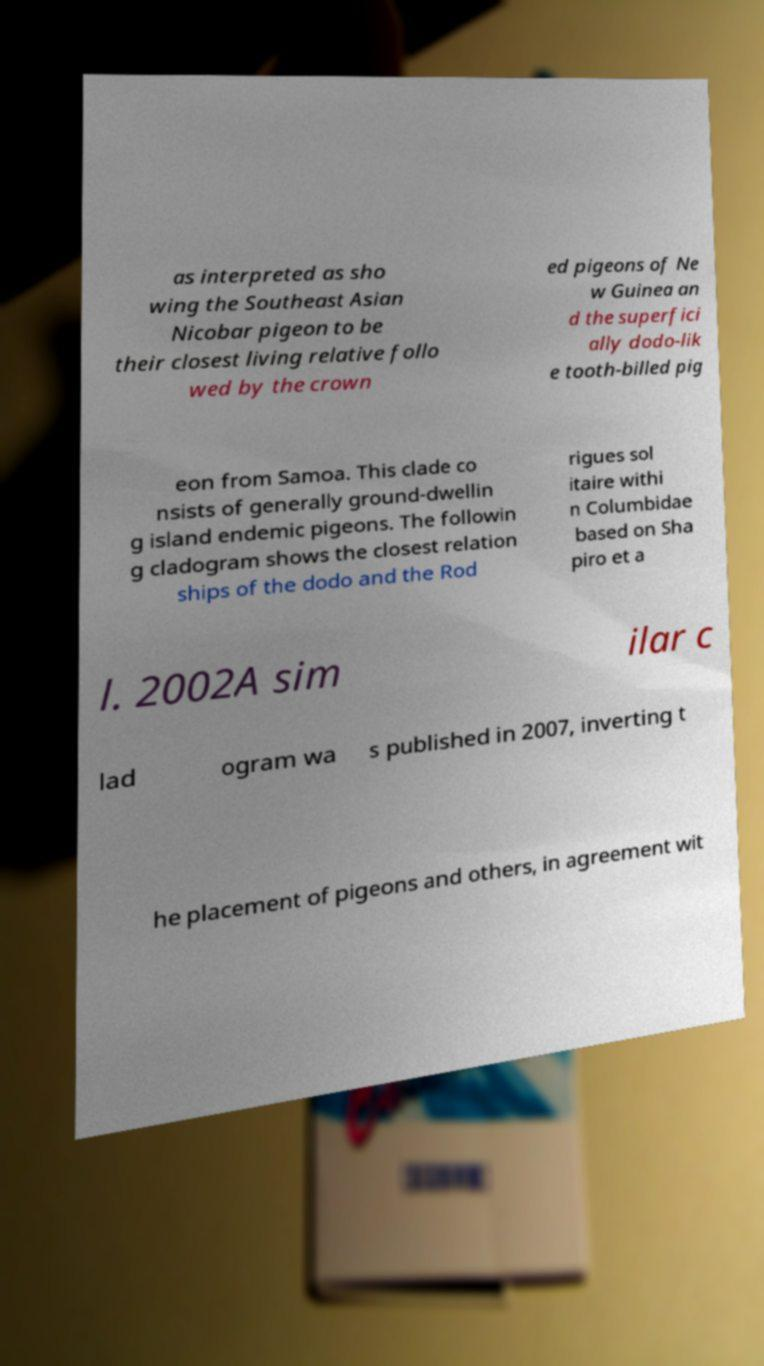Can you read and provide the text displayed in the image?This photo seems to have some interesting text. Can you extract and type it out for me? as interpreted as sho wing the Southeast Asian Nicobar pigeon to be their closest living relative follo wed by the crown ed pigeons of Ne w Guinea an d the superfici ally dodo-lik e tooth-billed pig eon from Samoa. This clade co nsists of generally ground-dwellin g island endemic pigeons. The followin g cladogram shows the closest relation ships of the dodo and the Rod rigues sol itaire withi n Columbidae based on Sha piro et a l. 2002A sim ilar c lad ogram wa s published in 2007, inverting t he placement of pigeons and others, in agreement wit 